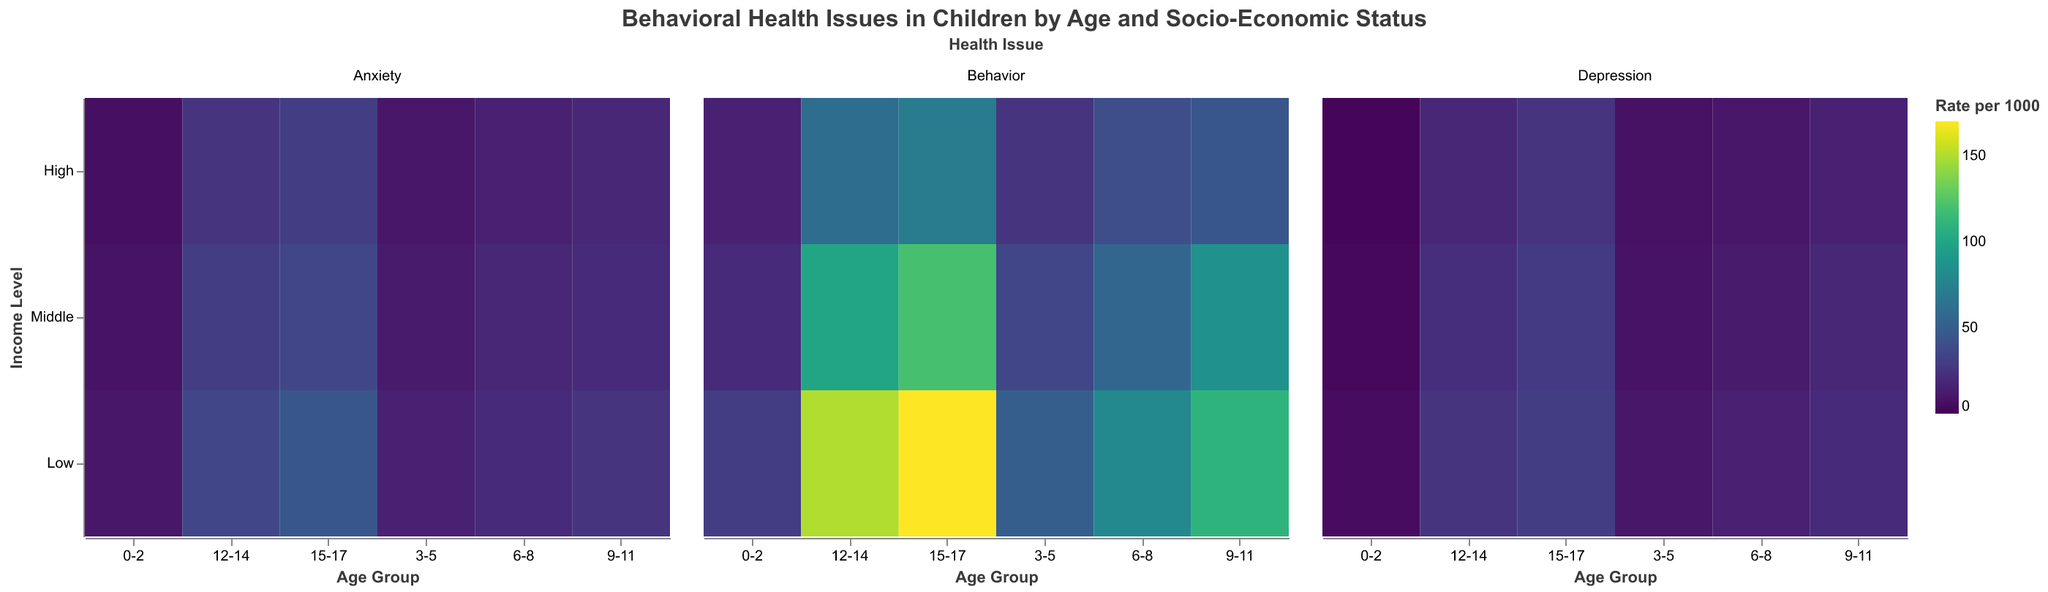What is the highest rate of behavior issues in any age group and income level? To find the highest rate, you look at the color scale and identify the darkest section in the entire heatmap. The darkest section in the "Behavior" facet represents the highest rate. This is found in the 15-17 age group for the Low Income level.
Answer: 170 per 1000 In which socio-economic group and age range is the rate of anxiety issues the highest? To find the highest rate of anxiety issues, look for the darkest color in the "Anxiety" facet. This appears in the 15-17 age group for the Low Income level.
Answer: Low Income, 15-17 years old How does the rate of depression issues in Middle Income children aged 9-11 compare to High Income children aged 6-8? In the "Depression" facet, find the rates for Middle Income & 9-11 (18 per 1000) and High Income & 6-8 (10 per 1000). Compare these values.
Answer: 18 per 1000 vs 10 per 1000 What is the average rate of behavior issues in the 3-5 age group across all income levels? Add the rates of behavior issues for all income levels in the 3-5 age group (50 for Low, 35 for Middle, 25 for High) and divide by 3. Calculation: (50 + 35 + 25) / 3 = 36.67
Answer: 36.67 per 1000 Does the rate of anxiety issues in children increase, decrease, or stay the same with age in the High Income group? Observe the "Anxiety" facet for the High Income group across different age ranges. Notice if the colors get progressively darker from left to right. The rate increases as the age group gets older.
Answer: Increase Which age group in the Low Income category shows the greatest increase in behavior issues compared to the previous age group? To find the greatest increase, compare the rates of behavior issues for consecutive age groups in the Low Income category. The greatest increase is from age group 6-8 (80 per 1000) to age group 9-11 (110 per 1000), an increase of 30 per 1000.
Answer: 6-8 to 9-11 years old What is the overall trend for depression rates in the Middle Income group as children age? Examine the "Depression" facet specifically for Middle Income across all age groups. The colors get progressively darker, suggesting an increase in the rate of depression issues as age increases.
Answer: Increase Comparing all rates of behavior issues in the 12-14 age group, which socio-economic status has the lowest rate and what is it? In the "Behavior" facet, find the rates for the 12-14 age group across all income levels. The High Income group has the lowest rate at 60 per 1000.
Answer: High Income, 60 per 1000 What is the difference in the rate of anxiety issues between Low Income and Middle Income children aged 0-2? In the "Anxiety" facet, find the rates for Low Income (10 per 1000) and Middle Income (8 per 1000) children aged 0-2. Subtract the lower rate from the higher rate. Calculation: 10 - 8 = 2
Answer: 2 per 1000 